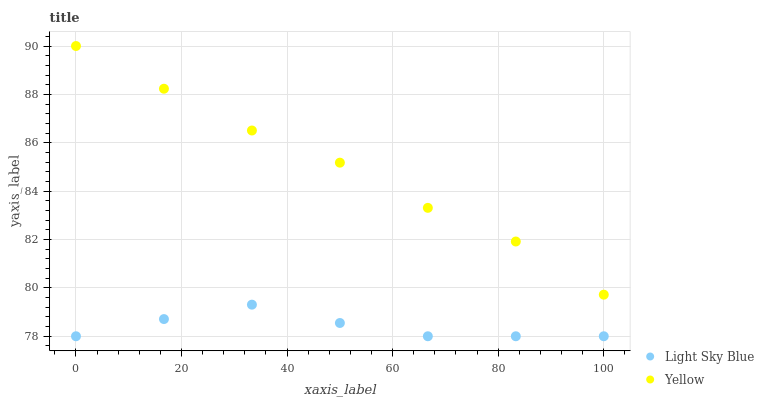Does Light Sky Blue have the minimum area under the curve?
Answer yes or no. Yes. Does Yellow have the maximum area under the curve?
Answer yes or no. Yes. Does Yellow have the minimum area under the curve?
Answer yes or no. No. Is Light Sky Blue the smoothest?
Answer yes or no. Yes. Is Yellow the roughest?
Answer yes or no. Yes. Is Yellow the smoothest?
Answer yes or no. No. Does Light Sky Blue have the lowest value?
Answer yes or no. Yes. Does Yellow have the lowest value?
Answer yes or no. No. Does Yellow have the highest value?
Answer yes or no. Yes. Is Light Sky Blue less than Yellow?
Answer yes or no. Yes. Is Yellow greater than Light Sky Blue?
Answer yes or no. Yes. Does Light Sky Blue intersect Yellow?
Answer yes or no. No. 